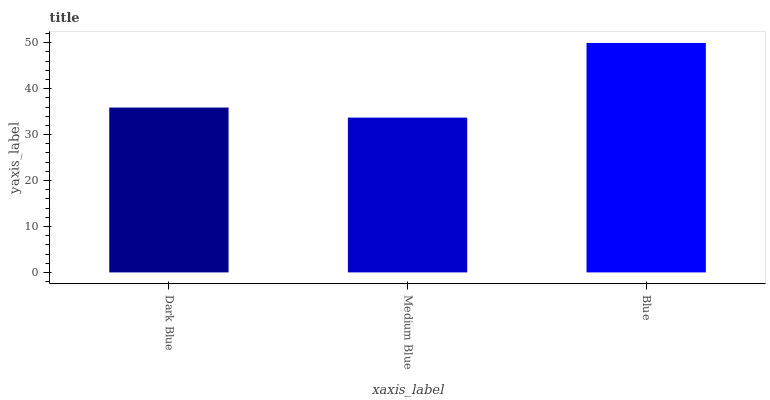Is Medium Blue the minimum?
Answer yes or no. Yes. Is Blue the maximum?
Answer yes or no. Yes. Is Blue the minimum?
Answer yes or no. No. Is Medium Blue the maximum?
Answer yes or no. No. Is Blue greater than Medium Blue?
Answer yes or no. Yes. Is Medium Blue less than Blue?
Answer yes or no. Yes. Is Medium Blue greater than Blue?
Answer yes or no. No. Is Blue less than Medium Blue?
Answer yes or no. No. Is Dark Blue the high median?
Answer yes or no. Yes. Is Dark Blue the low median?
Answer yes or no. Yes. Is Blue the high median?
Answer yes or no. No. Is Blue the low median?
Answer yes or no. No. 